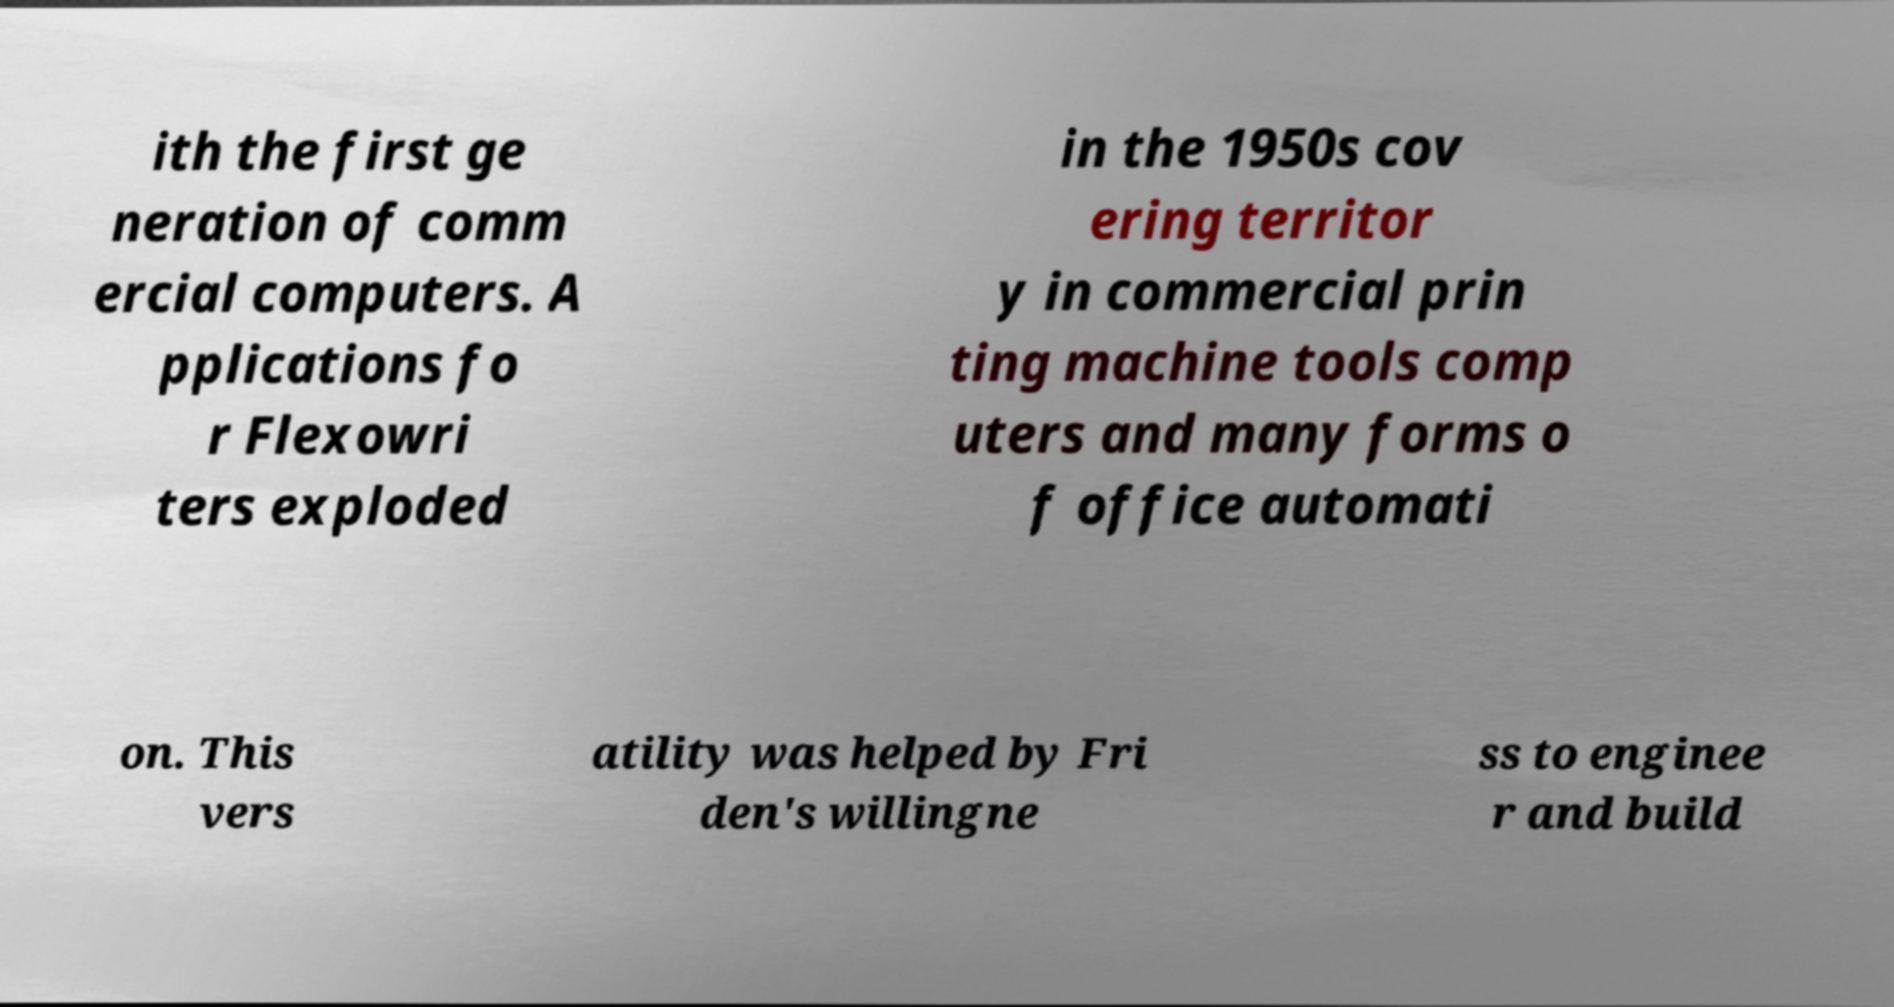I need the written content from this picture converted into text. Can you do that? ith the first ge neration of comm ercial computers. A pplications fo r Flexowri ters exploded in the 1950s cov ering territor y in commercial prin ting machine tools comp uters and many forms o f office automati on. This vers atility was helped by Fri den's willingne ss to enginee r and build 